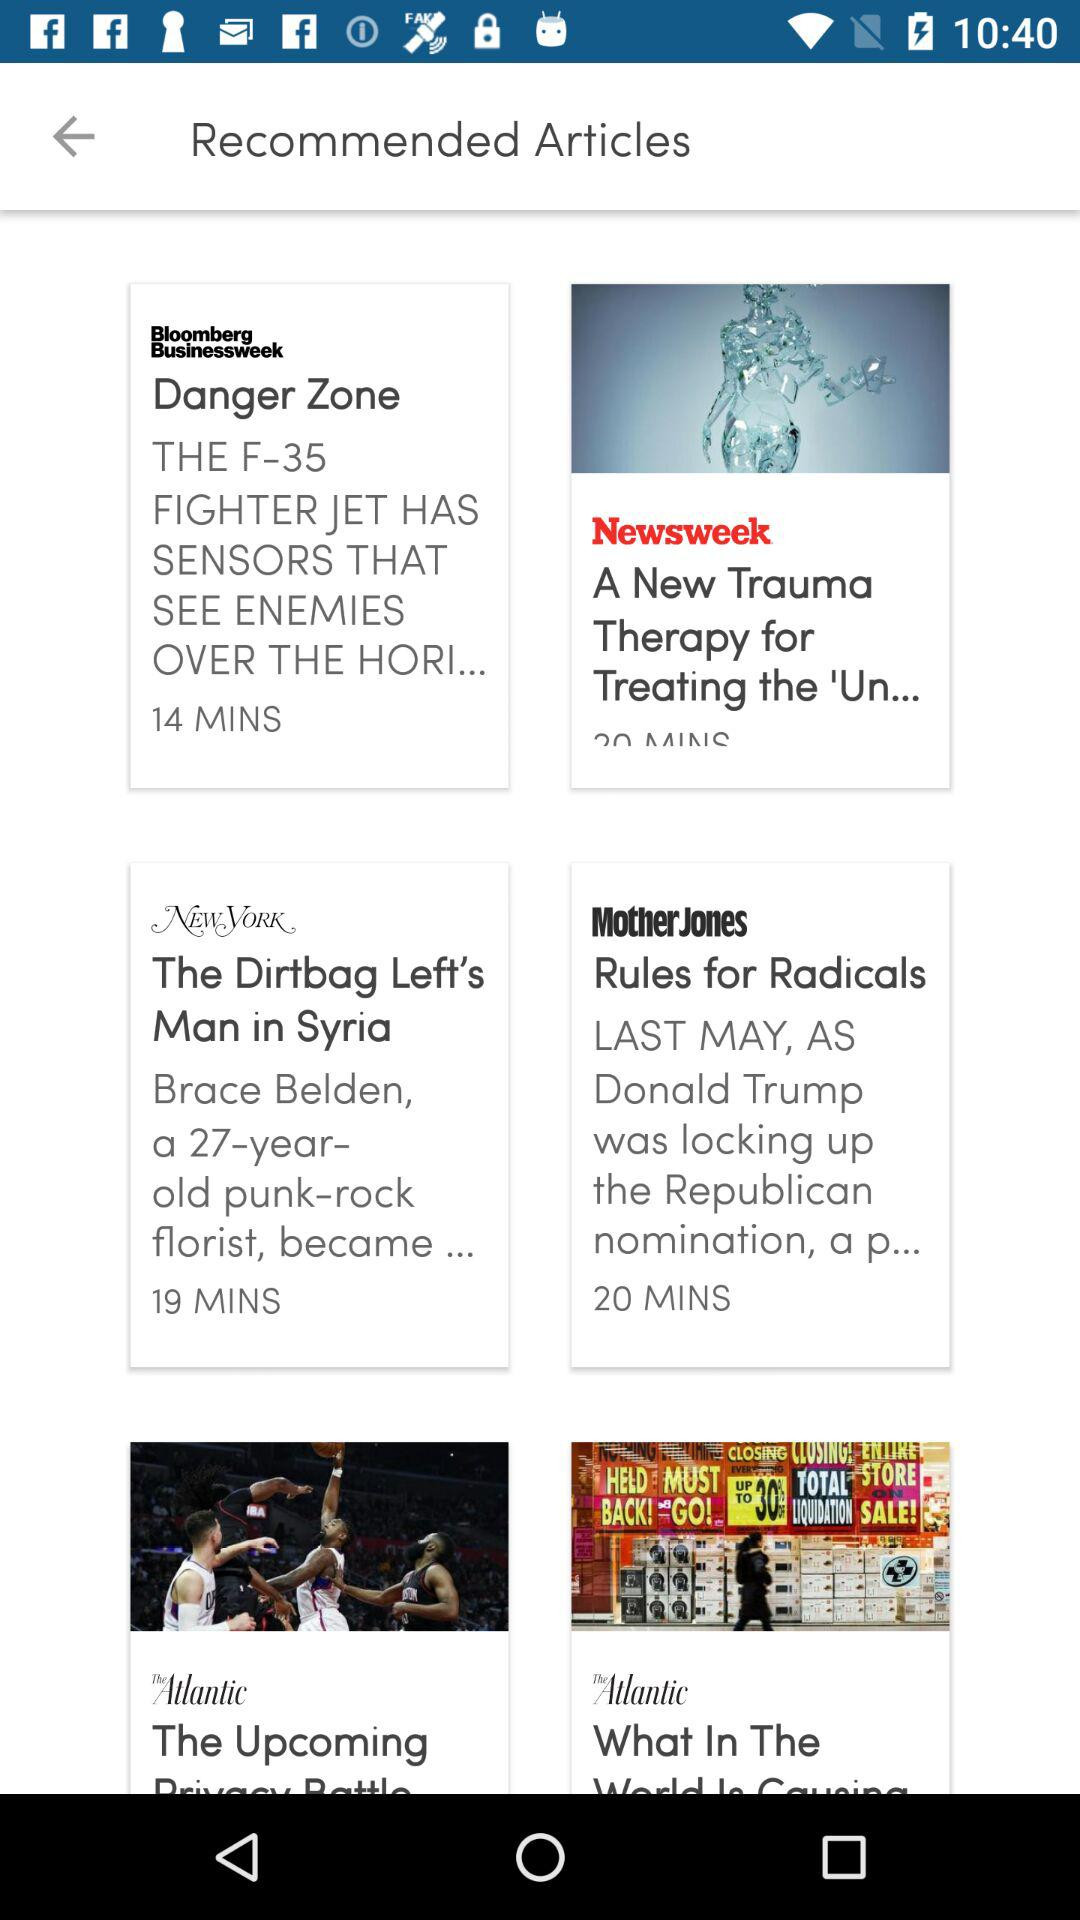How many articles are in the second row?
Answer the question using a single word or phrase. 2 